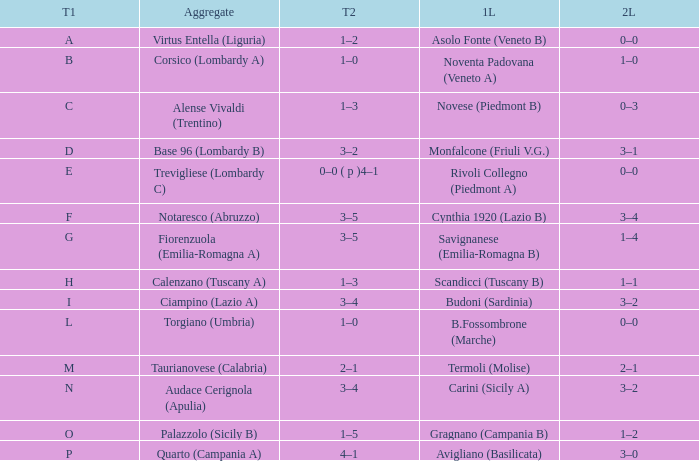What 1st leg has Alense Vivaldi (Trentino) as Agg.? Novese (Piedmont B). 